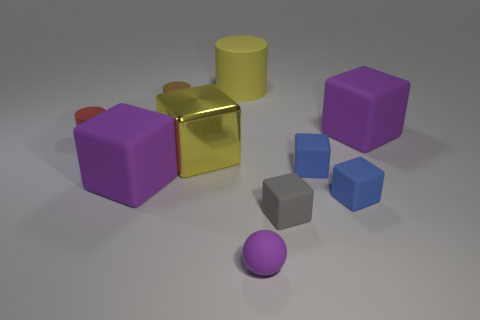Subtract all yellow cylinders. How many cylinders are left? 2 Subtract all gray balls. How many purple cubes are left? 2 Subtract all yellow cubes. How many cubes are left? 5 Subtract all brown blocks. Subtract all cyan spheres. How many blocks are left? 6 Subtract all spheres. How many objects are left? 9 Add 5 tiny red objects. How many tiny red objects are left? 6 Add 9 small red cylinders. How many small red cylinders exist? 10 Subtract 1 purple cubes. How many objects are left? 9 Subtract all big purple metal blocks. Subtract all tiny gray objects. How many objects are left? 9 